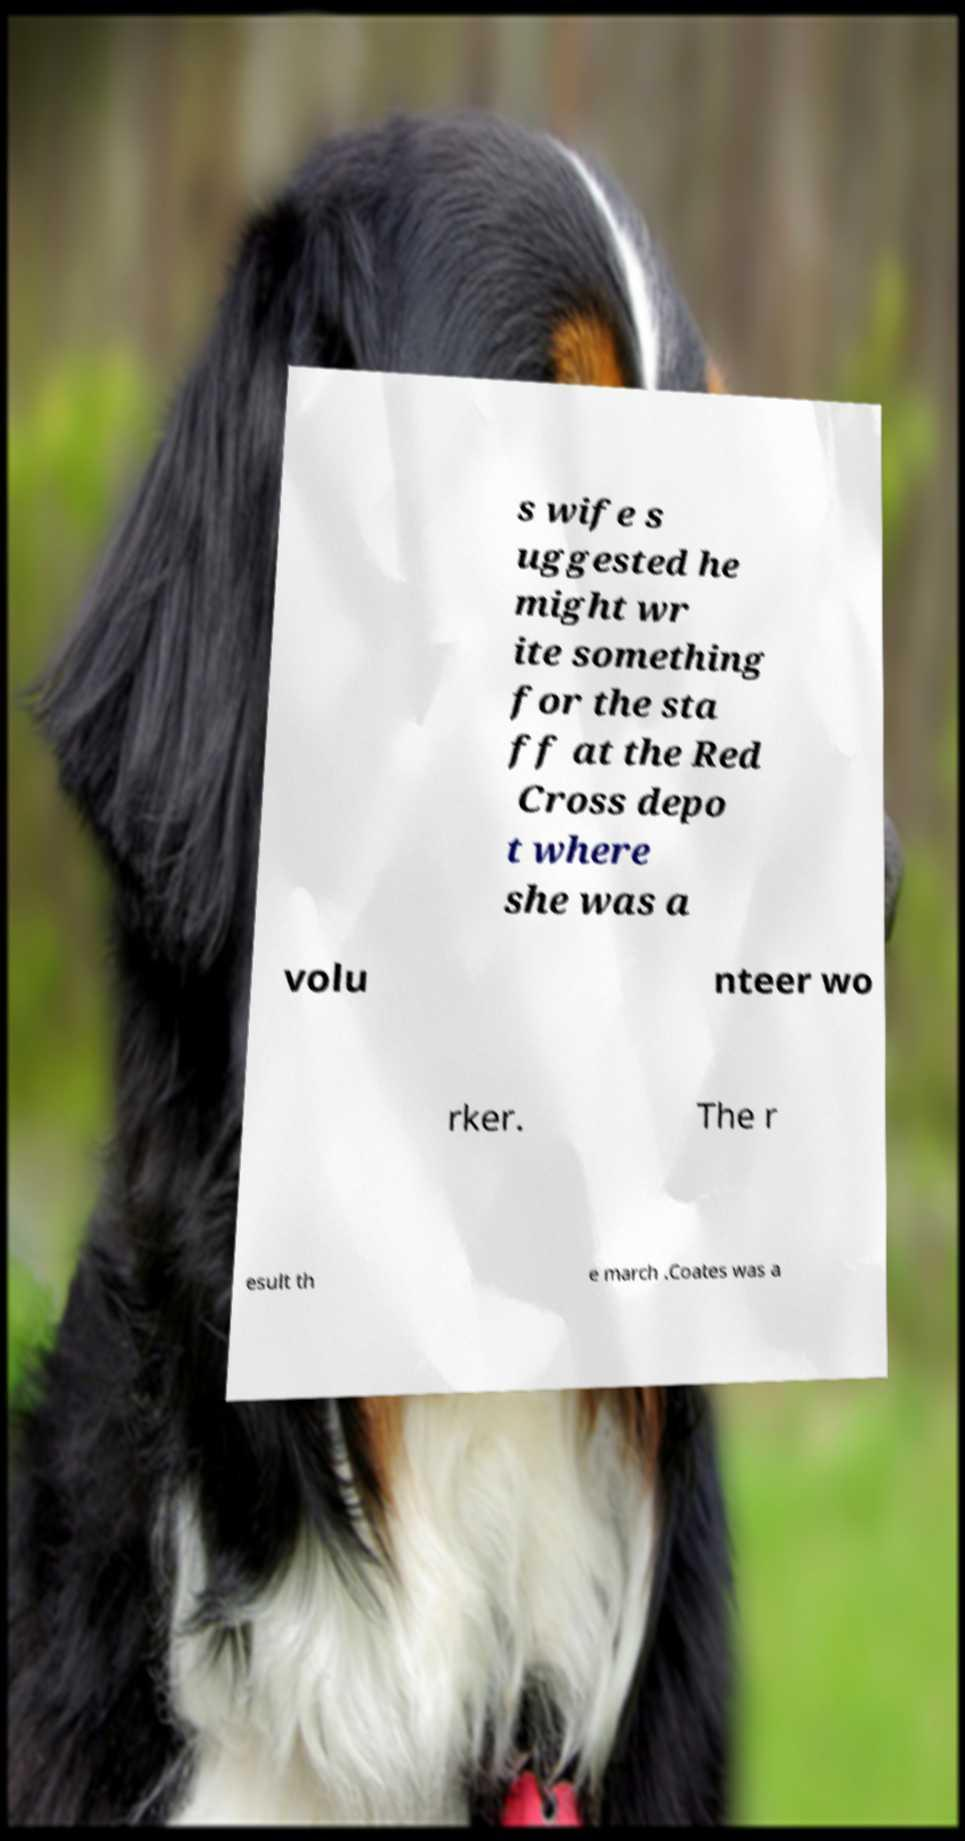Could you extract and type out the text from this image? s wife s uggested he might wr ite something for the sta ff at the Red Cross depo t where she was a volu nteer wo rker. The r esult th e march .Coates was a 